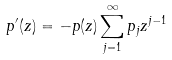Convert formula to latex. <formula><loc_0><loc_0><loc_500><loc_500>p ^ { \prime } ( z ) = - p ( z ) \sum _ { j = 1 } ^ { \infty } p _ { j } z ^ { j - 1 }</formula> 